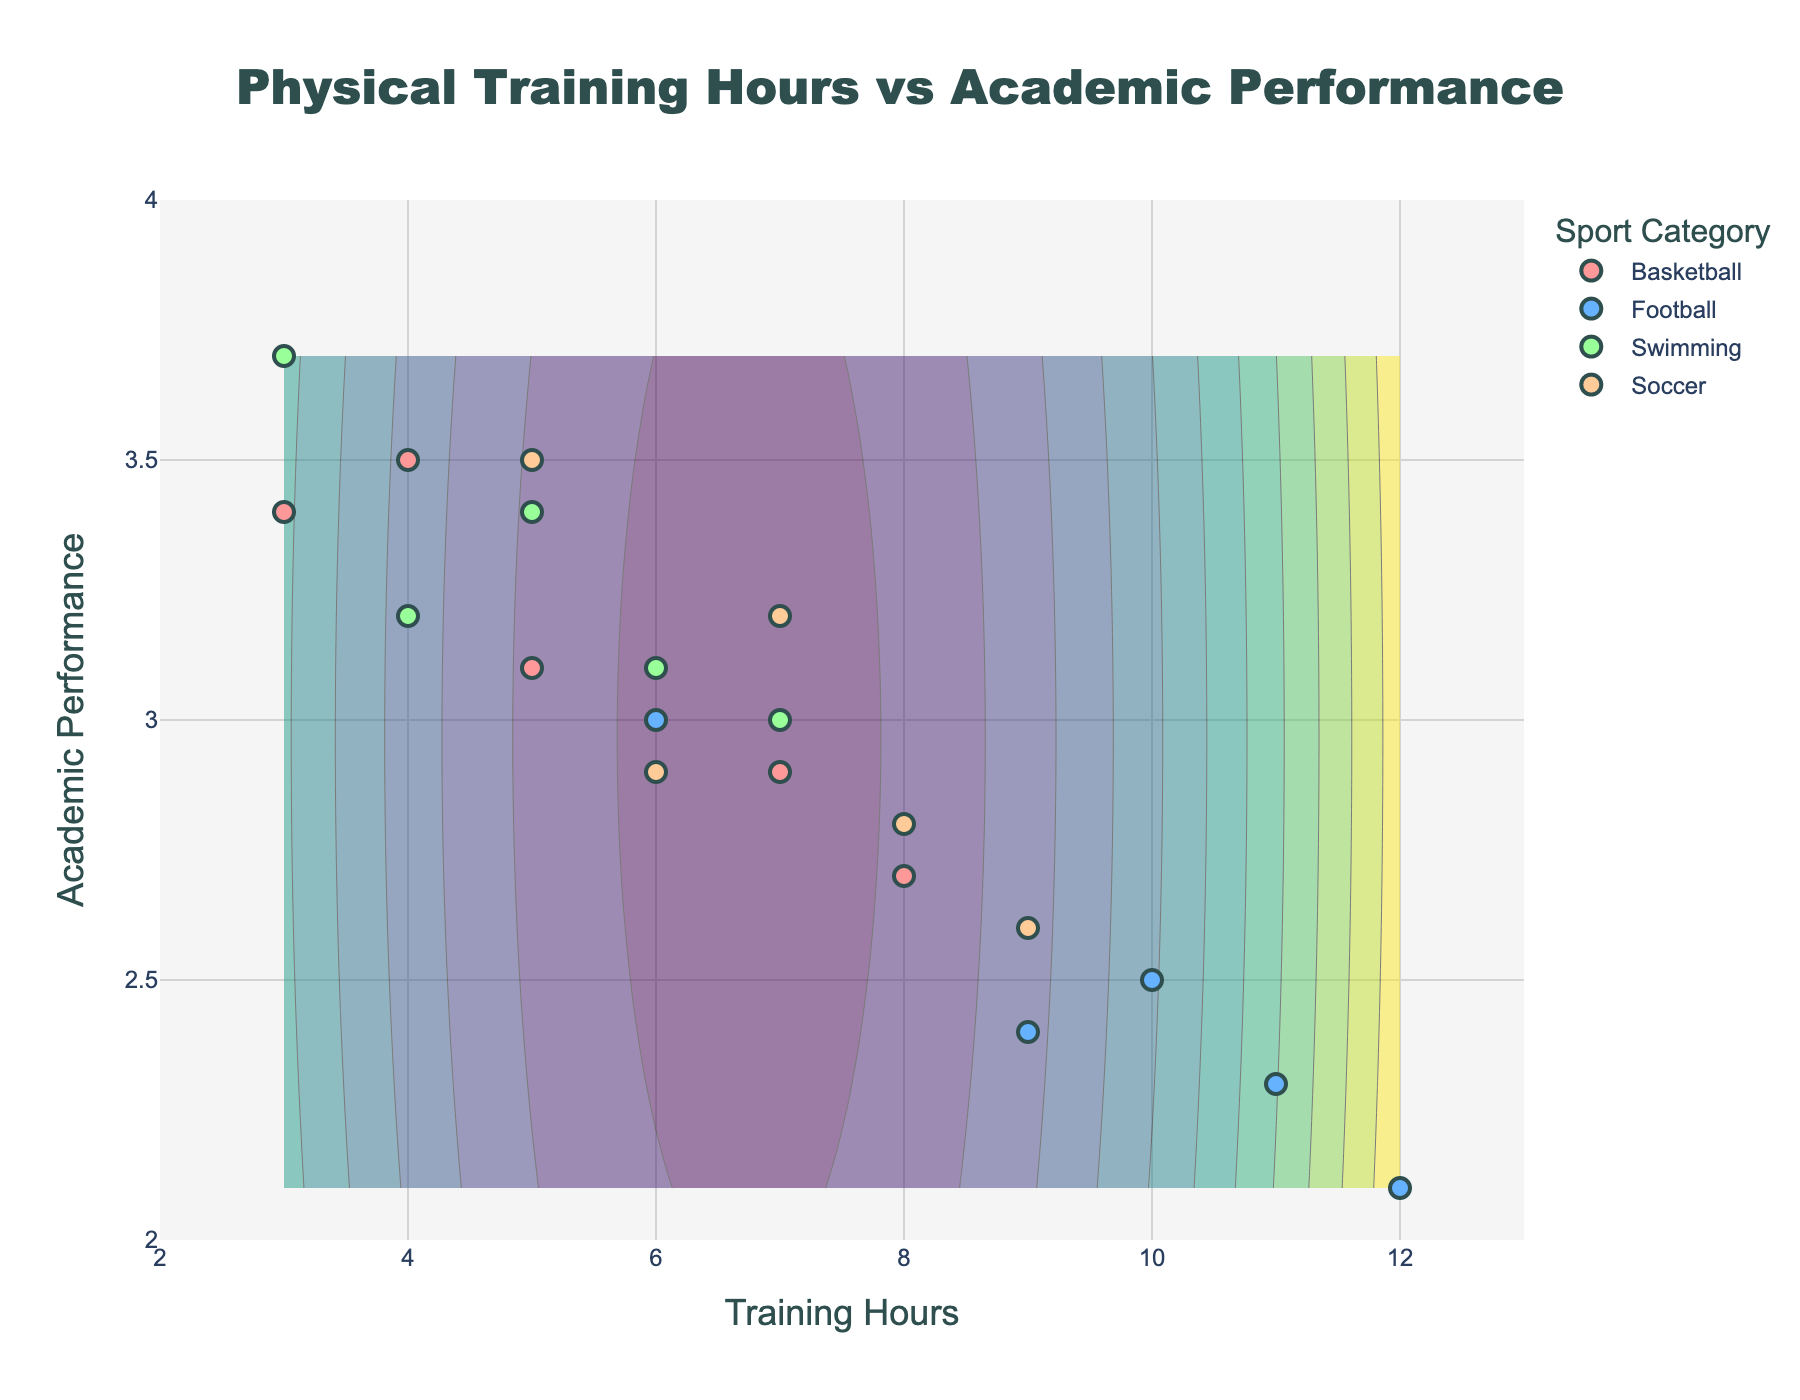What is the title of the plot? The plot title is displayed prominently at the top of the figure and reads "Physical Training Hours vs Academic Performance".
Answer: Physical Training Hours vs Academic Performance What does the x-axis represent? The label of the x-axis indicates it represents "Training Hours".
Answer: Training Hours Which sport category has the highest training hours? By looking at the scatter points, Football has the maximum training hours of 12.
Answer: Football What is the range of values shown on the y-axis? The y-axis shows values ranging from 2 to 4, as indicated by the axis limits.
Answer: 2 to 4 How many data points are there for Basketball? By counting the number of scatter points labeled as Basketball, we can see there are 5 data points.
Answer: 5 What sport category is associated with the academic performance value of 3.5? The scatter point at y=3.5 is labeled as Basketball.
Answer: Basketball What is the relationship between training hours and academic performance for Swimming? Observing the scatter points for Swimming, we can see an increasing trend in academic performance with decreasing training hours.
Answer: Inverse relationship Which sport category shows the greatest academic performance? The highest academic performance value is 3.7, which belongs to Swimming.
Answer: Swimming Which sport category demonstrates the most consistent academic performance? Swimming shows the most consistent academic performance as its data points are clustered closely around the 3.0 to 3.5 range.
Answer: Swimming Is there a visible trend between Training Hours and Academic Performance across all categories? The contour plot and scattered points suggest that as training hours increase, academic performance generally decreases.
Answer: Generally inverse trend 